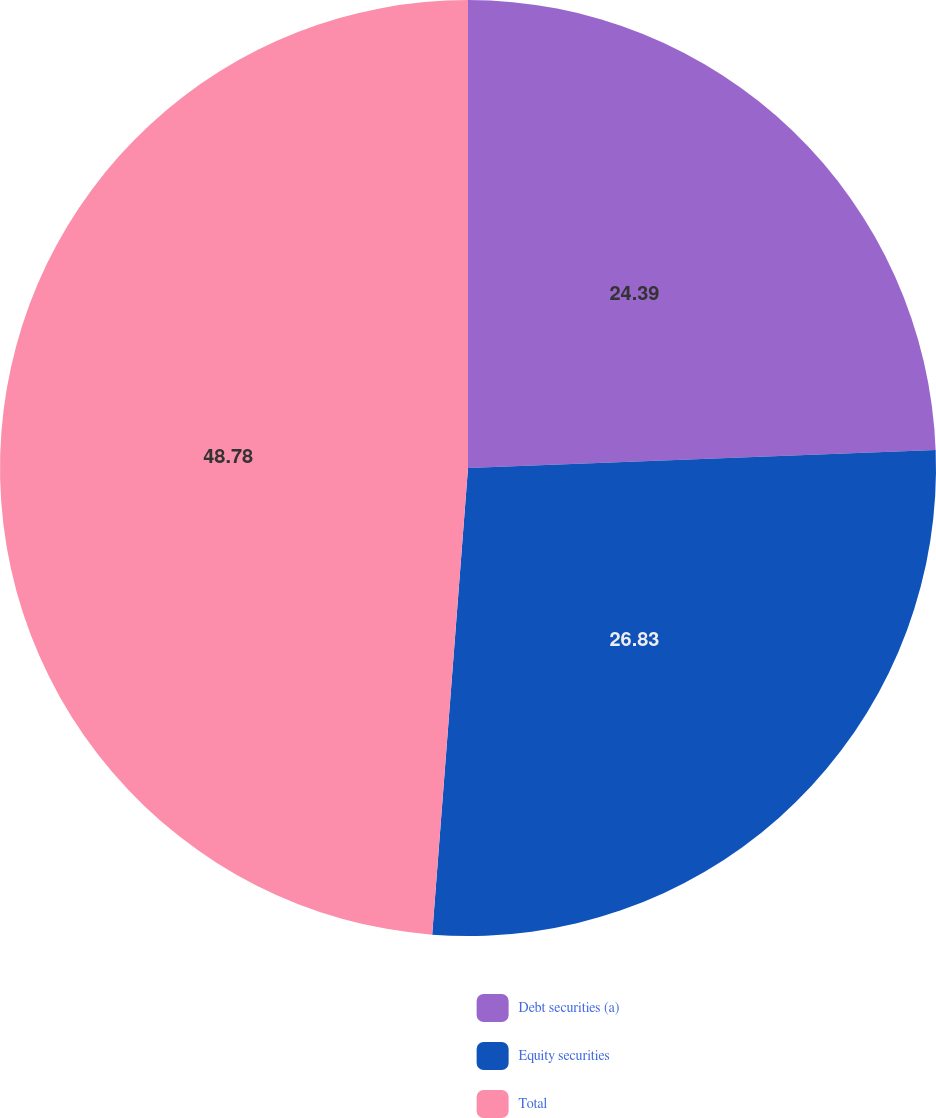<chart> <loc_0><loc_0><loc_500><loc_500><pie_chart><fcel>Debt securities (a)<fcel>Equity securities<fcel>Total<nl><fcel>24.39%<fcel>26.83%<fcel>48.78%<nl></chart> 